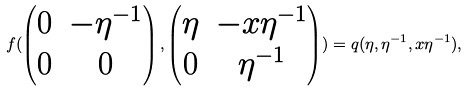Convert formula to latex. <formula><loc_0><loc_0><loc_500><loc_500>f ( \begin{pmatrix} 0 & - \eta ^ { - 1 } \\ 0 & 0 \end{pmatrix} , \begin{pmatrix} \eta & - x \eta ^ { - 1 } \\ 0 & \eta ^ { - 1 } \end{pmatrix} ) = q ( \eta , \eta ^ { - 1 } , x \eta ^ { - 1 } ) ,</formula> 